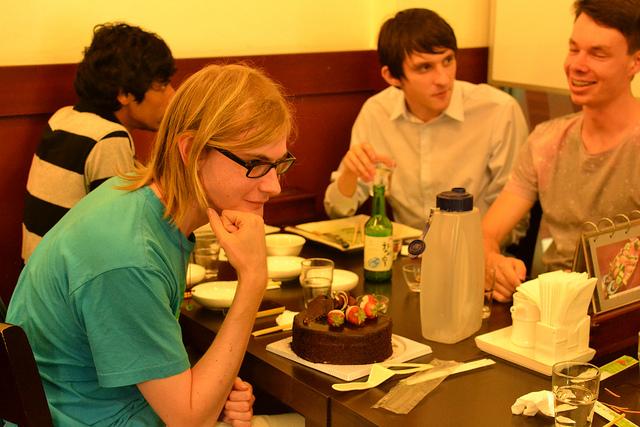How many people?
Be succinct. 4. Are these two young men having a good time?
Be succinct. Yes. How many hands can be seen?
Answer briefly. 4. What are these men doing?
Write a very short answer. Eating. Is everyone in this scene enjoying the conversation?
Short answer required. No. What color are the frames of the women's glasses?
Quick response, please. Black. 